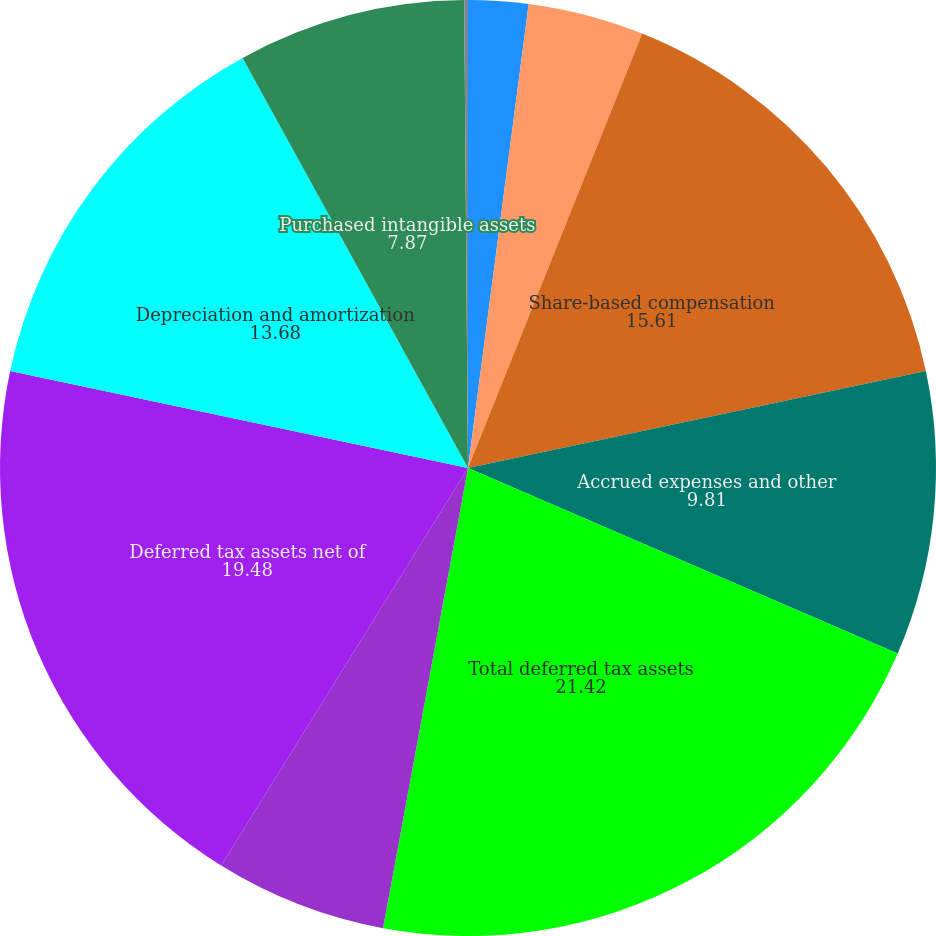Convert chart to OTSL. <chart><loc_0><loc_0><loc_500><loc_500><pie_chart><fcel>Net operating loss<fcel>Tax credit carryforward<fcel>Share-based compensation<fcel>Accrued expenses and other<fcel>Total deferred tax assets<fcel>Less valuation allowance<fcel>Deferred tax assets net of<fcel>Depreciation and amortization<fcel>Purchased intangible assets<fcel>Deferred foreign taxes<nl><fcel>2.07%<fcel>4.0%<fcel>15.61%<fcel>9.81%<fcel>21.42%<fcel>5.94%<fcel>19.48%<fcel>13.68%<fcel>7.87%<fcel>0.13%<nl></chart> 